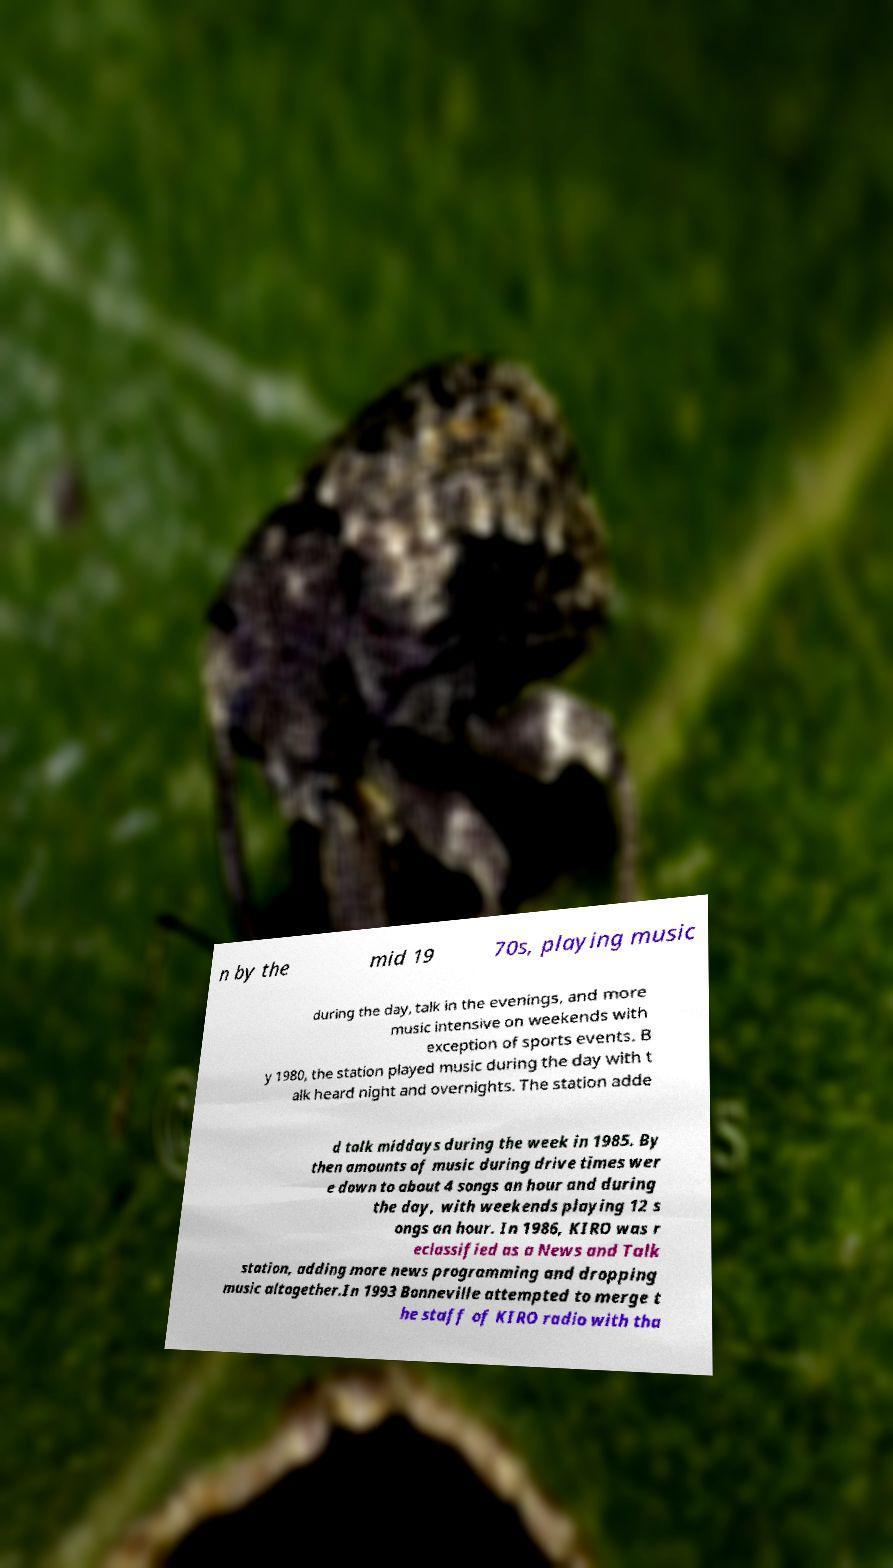Please read and relay the text visible in this image. What does it say? n by the mid 19 70s, playing music during the day, talk in the evenings, and more music intensive on weekends with exception of sports events. B y 1980, the station played music during the day with t alk heard night and overnights. The station adde d talk middays during the week in 1985. By then amounts of music during drive times wer e down to about 4 songs an hour and during the day, with weekends playing 12 s ongs an hour. In 1986, KIRO was r eclassified as a News and Talk station, adding more news programming and dropping music altogether.In 1993 Bonneville attempted to merge t he staff of KIRO radio with tha 